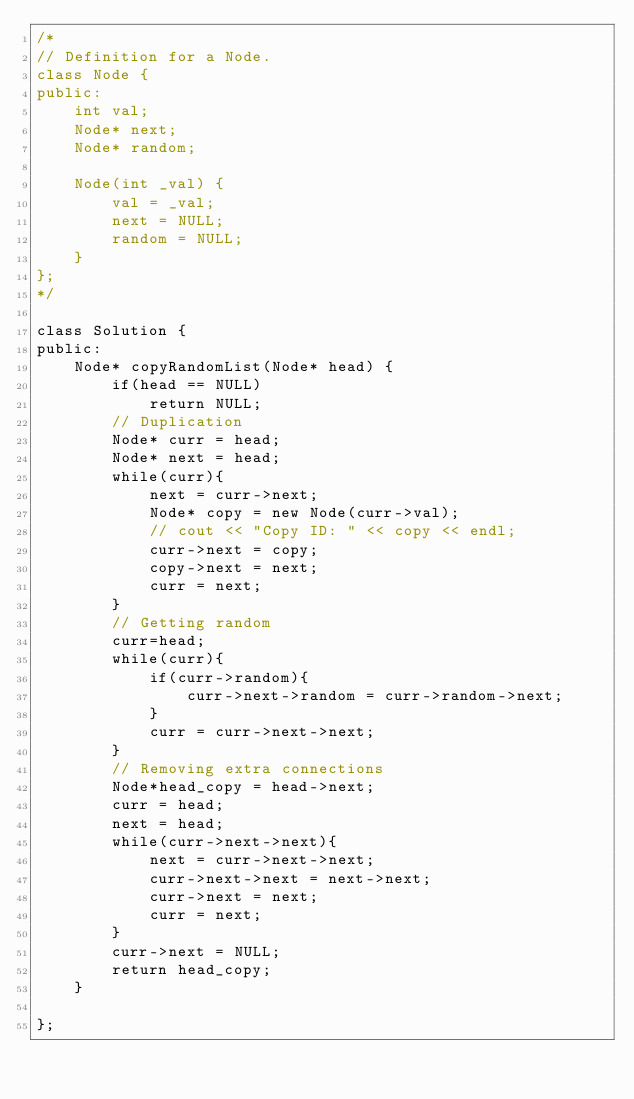Convert code to text. <code><loc_0><loc_0><loc_500><loc_500><_C++_>/*
// Definition for a Node.
class Node {
public:
    int val;
    Node* next;
    Node* random;
    
    Node(int _val) {
        val = _val;
        next = NULL;
        random = NULL;
    }
};
*/

class Solution {
public:
    Node* copyRandomList(Node* head) {
        if(head == NULL)
            return NULL;    
        // Duplication
        Node* curr = head;
        Node* next = head;
        while(curr){
            next = curr->next;
            Node* copy = new Node(curr->val);
            // cout << "Copy ID: " << copy << endl;
            curr->next = copy;
            copy->next = next;
            curr = next;
        }
        // Getting random
        curr=head;
        while(curr){
            if(curr->random){
                curr->next->random = curr->random->next;
            }
            curr = curr->next->next;
        }
        // Removing extra connections
        Node*head_copy = head->next;
        curr = head;
        next = head;
        while(curr->next->next){
            next = curr->next->next;
            curr->next->next = next->next;
            curr->next = next;
            curr = next;
        }
        curr->next = NULL;
        return head_copy;
    }
    
};

</code> 